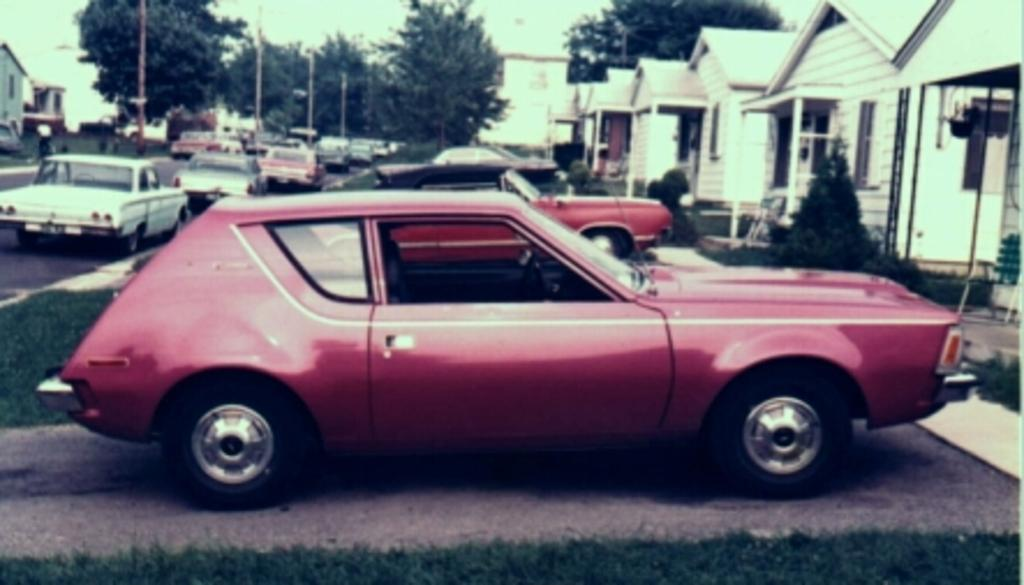What types of objects can be seen in the image? There are vehicles, houses, poles, and trees in the image. What is visible in the background of the image? The sky is visible in the image. What type of terrain is present in the image? There is grass visible in the image. How many ducks are sitting on the cannon in the image? There are no ducks or cannons present in the image. What discovery was made at the location depicted in the image? The image does not depict a specific discovery or event, so it is not possible to answer this question. 